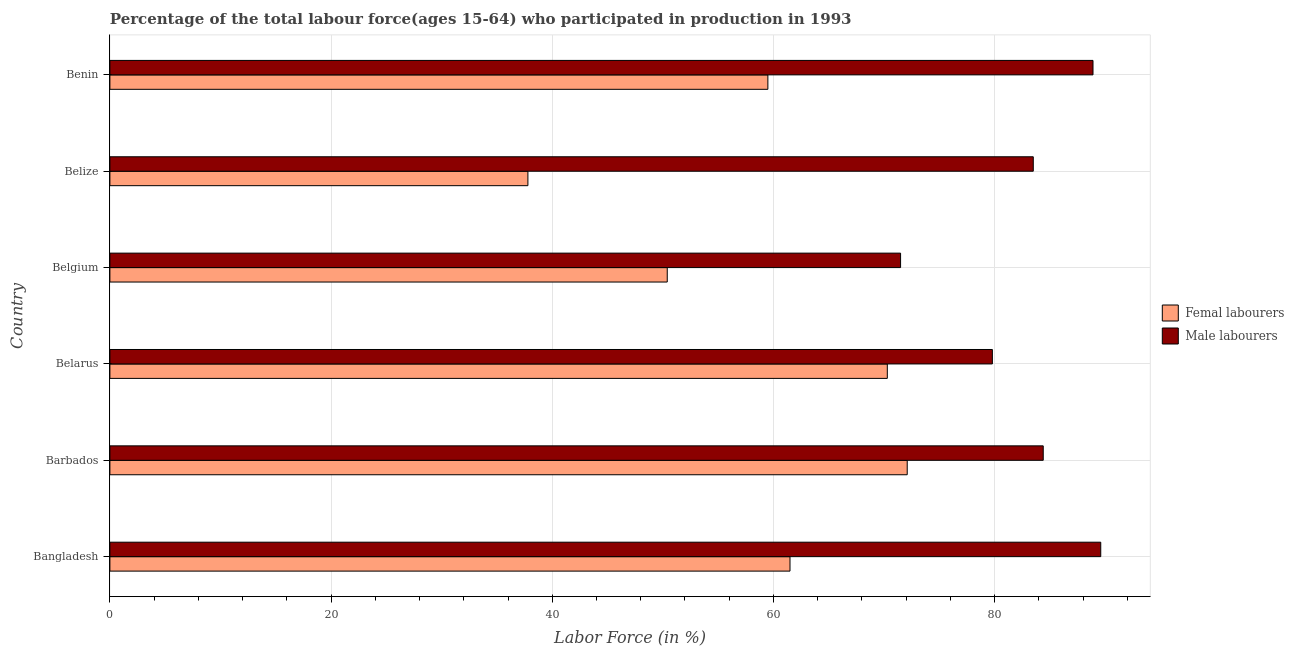How many different coloured bars are there?
Give a very brief answer. 2. Are the number of bars on each tick of the Y-axis equal?
Your answer should be very brief. Yes. How many bars are there on the 3rd tick from the bottom?
Provide a short and direct response. 2. In how many cases, is the number of bars for a given country not equal to the number of legend labels?
Ensure brevity in your answer.  0. What is the percentage of female labor force in Belize?
Make the answer very short. 37.8. Across all countries, what is the maximum percentage of female labor force?
Your answer should be very brief. 72.1. Across all countries, what is the minimum percentage of male labour force?
Keep it short and to the point. 71.5. In which country was the percentage of female labor force maximum?
Your answer should be very brief. Barbados. In which country was the percentage of female labor force minimum?
Keep it short and to the point. Belize. What is the total percentage of female labor force in the graph?
Your answer should be very brief. 351.6. What is the average percentage of male labour force per country?
Offer a terse response. 82.95. What is the difference between the percentage of male labour force and percentage of female labor force in Barbados?
Offer a terse response. 12.3. What is the ratio of the percentage of male labour force in Belarus to that in Benin?
Offer a terse response. 0.9. What is the difference between the highest and the second highest percentage of female labor force?
Offer a very short reply. 1.8. What is the difference between the highest and the lowest percentage of female labor force?
Keep it short and to the point. 34.3. In how many countries, is the percentage of male labour force greater than the average percentage of male labour force taken over all countries?
Offer a very short reply. 4. Is the sum of the percentage of male labour force in Barbados and Belize greater than the maximum percentage of female labor force across all countries?
Your answer should be very brief. Yes. What does the 2nd bar from the top in Barbados represents?
Offer a terse response. Femal labourers. What does the 2nd bar from the bottom in Benin represents?
Keep it short and to the point. Male labourers. How many bars are there?
Your response must be concise. 12. Are all the bars in the graph horizontal?
Provide a short and direct response. Yes. Are the values on the major ticks of X-axis written in scientific E-notation?
Provide a succinct answer. No. Does the graph contain grids?
Make the answer very short. Yes. How many legend labels are there?
Provide a short and direct response. 2. What is the title of the graph?
Make the answer very short. Percentage of the total labour force(ages 15-64) who participated in production in 1993. Does "Female" appear as one of the legend labels in the graph?
Ensure brevity in your answer.  No. What is the Labor Force (in %) in Femal labourers in Bangladesh?
Give a very brief answer. 61.5. What is the Labor Force (in %) in Male labourers in Bangladesh?
Offer a very short reply. 89.6. What is the Labor Force (in %) in Femal labourers in Barbados?
Offer a very short reply. 72.1. What is the Labor Force (in %) in Male labourers in Barbados?
Keep it short and to the point. 84.4. What is the Labor Force (in %) in Femal labourers in Belarus?
Your response must be concise. 70.3. What is the Labor Force (in %) in Male labourers in Belarus?
Your answer should be compact. 79.8. What is the Labor Force (in %) of Femal labourers in Belgium?
Offer a terse response. 50.4. What is the Labor Force (in %) of Male labourers in Belgium?
Offer a very short reply. 71.5. What is the Labor Force (in %) of Femal labourers in Belize?
Give a very brief answer. 37.8. What is the Labor Force (in %) in Male labourers in Belize?
Provide a succinct answer. 83.5. What is the Labor Force (in %) of Femal labourers in Benin?
Offer a very short reply. 59.5. What is the Labor Force (in %) of Male labourers in Benin?
Your answer should be compact. 88.9. Across all countries, what is the maximum Labor Force (in %) of Femal labourers?
Make the answer very short. 72.1. Across all countries, what is the maximum Labor Force (in %) in Male labourers?
Your answer should be compact. 89.6. Across all countries, what is the minimum Labor Force (in %) in Femal labourers?
Offer a very short reply. 37.8. Across all countries, what is the minimum Labor Force (in %) in Male labourers?
Your answer should be compact. 71.5. What is the total Labor Force (in %) of Femal labourers in the graph?
Provide a short and direct response. 351.6. What is the total Labor Force (in %) in Male labourers in the graph?
Provide a short and direct response. 497.7. What is the difference between the Labor Force (in %) of Femal labourers in Bangladesh and that in Barbados?
Provide a succinct answer. -10.6. What is the difference between the Labor Force (in %) in Femal labourers in Bangladesh and that in Belarus?
Make the answer very short. -8.8. What is the difference between the Labor Force (in %) of Male labourers in Bangladesh and that in Belarus?
Offer a terse response. 9.8. What is the difference between the Labor Force (in %) in Femal labourers in Bangladesh and that in Belgium?
Make the answer very short. 11.1. What is the difference between the Labor Force (in %) in Male labourers in Bangladesh and that in Belgium?
Your answer should be very brief. 18.1. What is the difference between the Labor Force (in %) in Femal labourers in Bangladesh and that in Belize?
Provide a short and direct response. 23.7. What is the difference between the Labor Force (in %) in Male labourers in Bangladesh and that in Belize?
Offer a terse response. 6.1. What is the difference between the Labor Force (in %) of Femal labourers in Bangladesh and that in Benin?
Your response must be concise. 2. What is the difference between the Labor Force (in %) in Male labourers in Bangladesh and that in Benin?
Your response must be concise. 0.7. What is the difference between the Labor Force (in %) in Femal labourers in Barbados and that in Belarus?
Keep it short and to the point. 1.8. What is the difference between the Labor Force (in %) of Male labourers in Barbados and that in Belarus?
Offer a very short reply. 4.6. What is the difference between the Labor Force (in %) in Femal labourers in Barbados and that in Belgium?
Your answer should be compact. 21.7. What is the difference between the Labor Force (in %) of Femal labourers in Barbados and that in Belize?
Your response must be concise. 34.3. What is the difference between the Labor Force (in %) of Male labourers in Barbados and that in Belize?
Your answer should be very brief. 0.9. What is the difference between the Labor Force (in %) in Femal labourers in Barbados and that in Benin?
Ensure brevity in your answer.  12.6. What is the difference between the Labor Force (in %) of Femal labourers in Belarus and that in Belgium?
Make the answer very short. 19.9. What is the difference between the Labor Force (in %) of Male labourers in Belarus and that in Belgium?
Ensure brevity in your answer.  8.3. What is the difference between the Labor Force (in %) in Femal labourers in Belarus and that in Belize?
Ensure brevity in your answer.  32.5. What is the difference between the Labor Force (in %) of Male labourers in Belarus and that in Belize?
Your answer should be very brief. -3.7. What is the difference between the Labor Force (in %) in Male labourers in Belgium and that in Benin?
Provide a succinct answer. -17.4. What is the difference between the Labor Force (in %) in Femal labourers in Belize and that in Benin?
Make the answer very short. -21.7. What is the difference between the Labor Force (in %) in Male labourers in Belize and that in Benin?
Your response must be concise. -5.4. What is the difference between the Labor Force (in %) of Femal labourers in Bangladesh and the Labor Force (in %) of Male labourers in Barbados?
Give a very brief answer. -22.9. What is the difference between the Labor Force (in %) in Femal labourers in Bangladesh and the Labor Force (in %) in Male labourers in Belarus?
Give a very brief answer. -18.3. What is the difference between the Labor Force (in %) in Femal labourers in Bangladesh and the Labor Force (in %) in Male labourers in Belize?
Offer a terse response. -22. What is the difference between the Labor Force (in %) in Femal labourers in Bangladesh and the Labor Force (in %) in Male labourers in Benin?
Offer a very short reply. -27.4. What is the difference between the Labor Force (in %) in Femal labourers in Barbados and the Labor Force (in %) in Male labourers in Belarus?
Provide a short and direct response. -7.7. What is the difference between the Labor Force (in %) of Femal labourers in Barbados and the Labor Force (in %) of Male labourers in Belize?
Make the answer very short. -11.4. What is the difference between the Labor Force (in %) in Femal labourers in Barbados and the Labor Force (in %) in Male labourers in Benin?
Keep it short and to the point. -16.8. What is the difference between the Labor Force (in %) in Femal labourers in Belarus and the Labor Force (in %) in Male labourers in Benin?
Keep it short and to the point. -18.6. What is the difference between the Labor Force (in %) in Femal labourers in Belgium and the Labor Force (in %) in Male labourers in Belize?
Make the answer very short. -33.1. What is the difference between the Labor Force (in %) in Femal labourers in Belgium and the Labor Force (in %) in Male labourers in Benin?
Keep it short and to the point. -38.5. What is the difference between the Labor Force (in %) in Femal labourers in Belize and the Labor Force (in %) in Male labourers in Benin?
Offer a very short reply. -51.1. What is the average Labor Force (in %) of Femal labourers per country?
Offer a very short reply. 58.6. What is the average Labor Force (in %) in Male labourers per country?
Ensure brevity in your answer.  82.95. What is the difference between the Labor Force (in %) of Femal labourers and Labor Force (in %) of Male labourers in Bangladesh?
Offer a terse response. -28.1. What is the difference between the Labor Force (in %) in Femal labourers and Labor Force (in %) in Male labourers in Barbados?
Provide a succinct answer. -12.3. What is the difference between the Labor Force (in %) of Femal labourers and Labor Force (in %) of Male labourers in Belgium?
Your answer should be very brief. -21.1. What is the difference between the Labor Force (in %) of Femal labourers and Labor Force (in %) of Male labourers in Belize?
Make the answer very short. -45.7. What is the difference between the Labor Force (in %) of Femal labourers and Labor Force (in %) of Male labourers in Benin?
Make the answer very short. -29.4. What is the ratio of the Labor Force (in %) in Femal labourers in Bangladesh to that in Barbados?
Make the answer very short. 0.85. What is the ratio of the Labor Force (in %) in Male labourers in Bangladesh to that in Barbados?
Keep it short and to the point. 1.06. What is the ratio of the Labor Force (in %) of Femal labourers in Bangladesh to that in Belarus?
Offer a terse response. 0.87. What is the ratio of the Labor Force (in %) of Male labourers in Bangladesh to that in Belarus?
Keep it short and to the point. 1.12. What is the ratio of the Labor Force (in %) in Femal labourers in Bangladesh to that in Belgium?
Offer a very short reply. 1.22. What is the ratio of the Labor Force (in %) in Male labourers in Bangladesh to that in Belgium?
Keep it short and to the point. 1.25. What is the ratio of the Labor Force (in %) of Femal labourers in Bangladesh to that in Belize?
Offer a terse response. 1.63. What is the ratio of the Labor Force (in %) in Male labourers in Bangladesh to that in Belize?
Give a very brief answer. 1.07. What is the ratio of the Labor Force (in %) in Femal labourers in Bangladesh to that in Benin?
Provide a succinct answer. 1.03. What is the ratio of the Labor Force (in %) of Male labourers in Bangladesh to that in Benin?
Give a very brief answer. 1.01. What is the ratio of the Labor Force (in %) of Femal labourers in Barbados to that in Belarus?
Give a very brief answer. 1.03. What is the ratio of the Labor Force (in %) of Male labourers in Barbados to that in Belarus?
Offer a very short reply. 1.06. What is the ratio of the Labor Force (in %) of Femal labourers in Barbados to that in Belgium?
Your answer should be compact. 1.43. What is the ratio of the Labor Force (in %) of Male labourers in Barbados to that in Belgium?
Ensure brevity in your answer.  1.18. What is the ratio of the Labor Force (in %) in Femal labourers in Barbados to that in Belize?
Your answer should be very brief. 1.91. What is the ratio of the Labor Force (in %) in Male labourers in Barbados to that in Belize?
Offer a very short reply. 1.01. What is the ratio of the Labor Force (in %) of Femal labourers in Barbados to that in Benin?
Your answer should be very brief. 1.21. What is the ratio of the Labor Force (in %) of Male labourers in Barbados to that in Benin?
Make the answer very short. 0.95. What is the ratio of the Labor Force (in %) in Femal labourers in Belarus to that in Belgium?
Provide a succinct answer. 1.39. What is the ratio of the Labor Force (in %) of Male labourers in Belarus to that in Belgium?
Ensure brevity in your answer.  1.12. What is the ratio of the Labor Force (in %) of Femal labourers in Belarus to that in Belize?
Your answer should be compact. 1.86. What is the ratio of the Labor Force (in %) in Male labourers in Belarus to that in Belize?
Offer a terse response. 0.96. What is the ratio of the Labor Force (in %) of Femal labourers in Belarus to that in Benin?
Give a very brief answer. 1.18. What is the ratio of the Labor Force (in %) of Male labourers in Belarus to that in Benin?
Keep it short and to the point. 0.9. What is the ratio of the Labor Force (in %) in Male labourers in Belgium to that in Belize?
Your response must be concise. 0.86. What is the ratio of the Labor Force (in %) in Femal labourers in Belgium to that in Benin?
Ensure brevity in your answer.  0.85. What is the ratio of the Labor Force (in %) in Male labourers in Belgium to that in Benin?
Your response must be concise. 0.8. What is the ratio of the Labor Force (in %) in Femal labourers in Belize to that in Benin?
Your answer should be very brief. 0.64. What is the ratio of the Labor Force (in %) in Male labourers in Belize to that in Benin?
Your response must be concise. 0.94. What is the difference between the highest and the lowest Labor Force (in %) in Femal labourers?
Give a very brief answer. 34.3. What is the difference between the highest and the lowest Labor Force (in %) in Male labourers?
Ensure brevity in your answer.  18.1. 